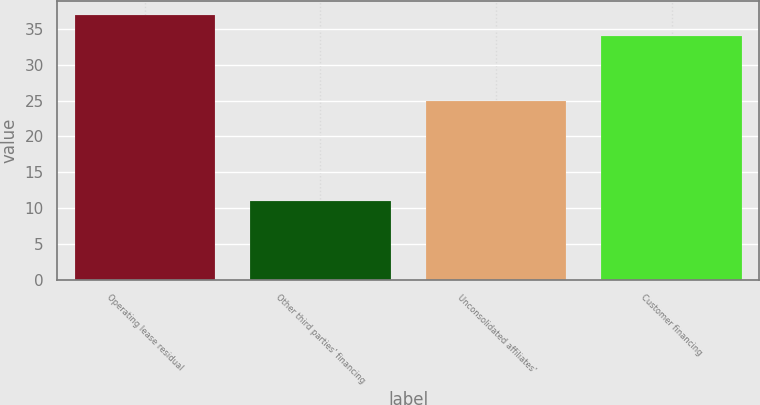<chart> <loc_0><loc_0><loc_500><loc_500><bar_chart><fcel>Operating lease residual<fcel>Other third parties' financing<fcel>Unconsolidated affiliates'<fcel>Customer financing<nl><fcel>37<fcel>11<fcel>25<fcel>34<nl></chart> 